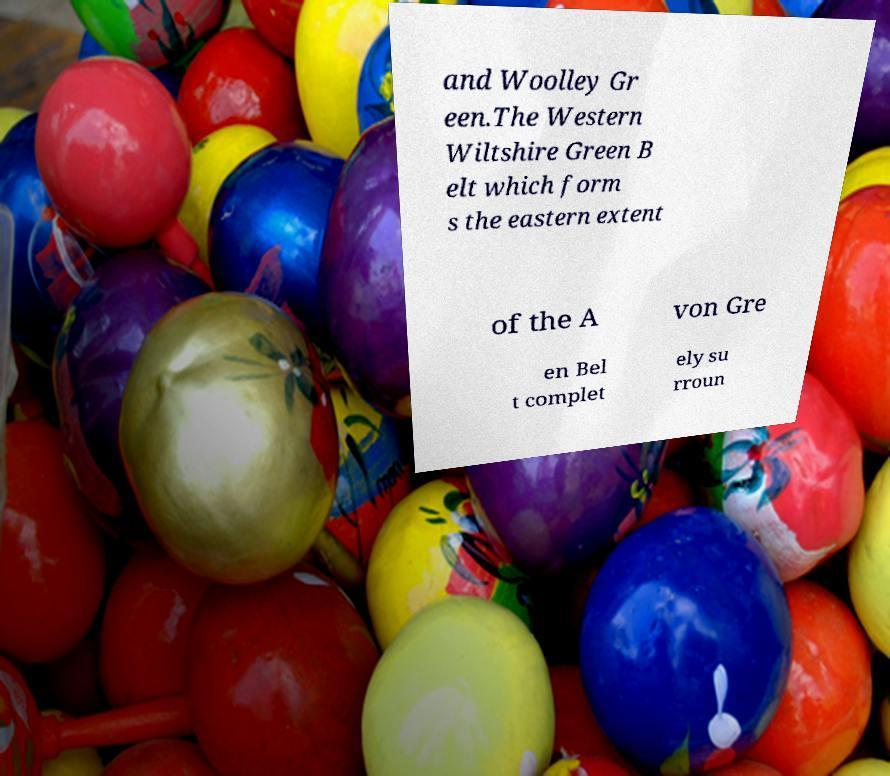I need the written content from this picture converted into text. Can you do that? and Woolley Gr een.The Western Wiltshire Green B elt which form s the eastern extent of the A von Gre en Bel t complet ely su rroun 